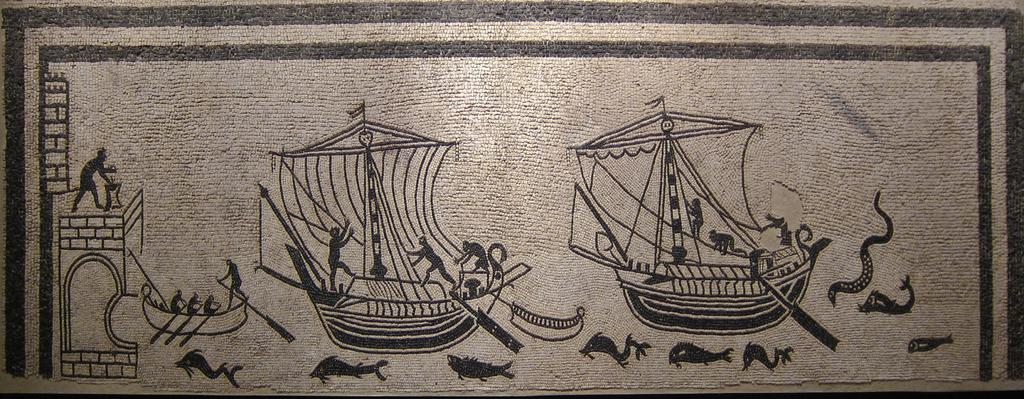What is the main subject of the image? The image contains an art piece. What is happening in the art piece? The art piece depicts persons on boats. Are there any other elements present in the image besides the boats and persons? Yes, there are fishes at the bottom of the image. What type of silver material can be seen in the image? There is no silver material present in the image. Can you describe the flesh of the persons depicted in the image? The image does not provide enough detail to describe the flesh of the persons depicted. 